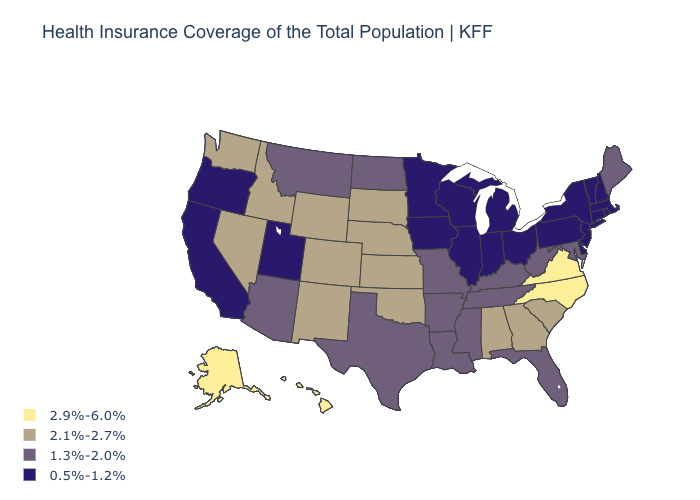What is the highest value in the MidWest ?
Quick response, please. 2.1%-2.7%. What is the lowest value in states that border North Carolina?
Give a very brief answer. 1.3%-2.0%. Is the legend a continuous bar?
Write a very short answer. No. Does Virginia have the lowest value in the USA?
Concise answer only. No. Is the legend a continuous bar?
Keep it brief. No. Name the states that have a value in the range 0.5%-1.2%?
Keep it brief. California, Connecticut, Delaware, Illinois, Indiana, Iowa, Massachusetts, Michigan, Minnesota, New Hampshire, New Jersey, New York, Ohio, Oregon, Pennsylvania, Rhode Island, Utah, Vermont, Wisconsin. What is the highest value in the USA?
Give a very brief answer. 2.9%-6.0%. Which states have the lowest value in the USA?
Keep it brief. California, Connecticut, Delaware, Illinois, Indiana, Iowa, Massachusetts, Michigan, Minnesota, New Hampshire, New Jersey, New York, Ohio, Oregon, Pennsylvania, Rhode Island, Utah, Vermont, Wisconsin. Is the legend a continuous bar?
Quick response, please. No. Does Wisconsin have a lower value than Rhode Island?
Concise answer only. No. What is the value of Rhode Island?
Quick response, please. 0.5%-1.2%. Name the states that have a value in the range 2.1%-2.7%?
Be succinct. Alabama, Colorado, Georgia, Idaho, Kansas, Nebraska, Nevada, New Mexico, Oklahoma, South Carolina, South Dakota, Washington, Wyoming. Does Maine have the lowest value in the Northeast?
Short answer required. No. Does the map have missing data?
Be succinct. No. What is the value of Virginia?
Keep it brief. 2.9%-6.0%. 